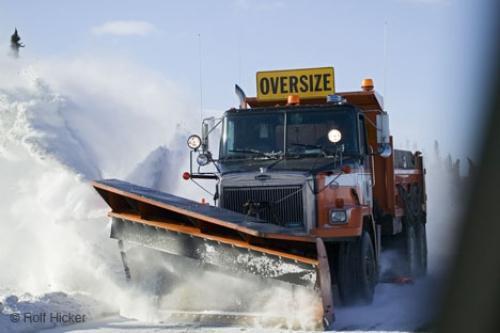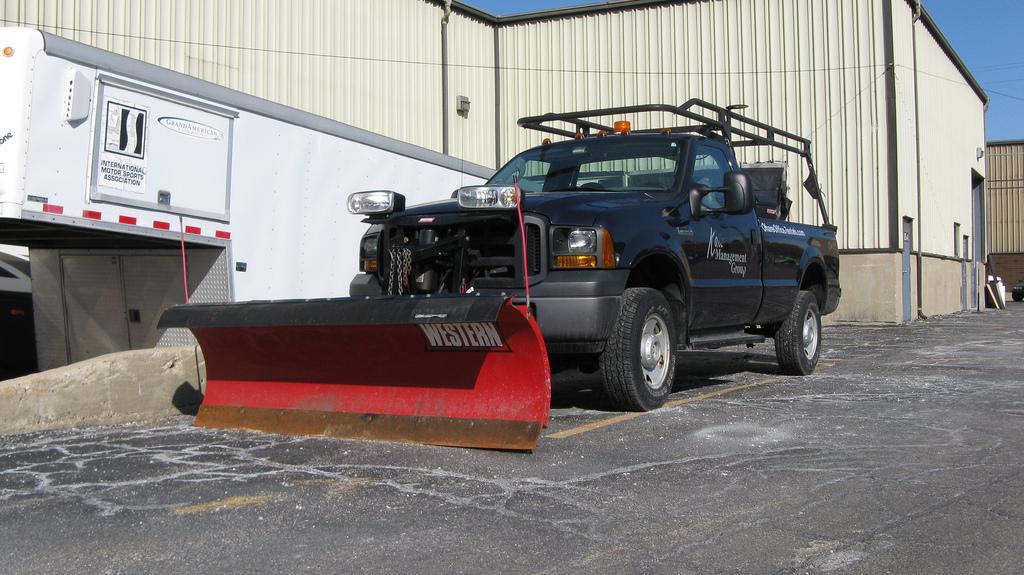The first image is the image on the left, the second image is the image on the right. Examine the images to the left and right. Is the description "The left and right image contains the same number of orange snow trucks." accurate? Answer yes or no. No. 